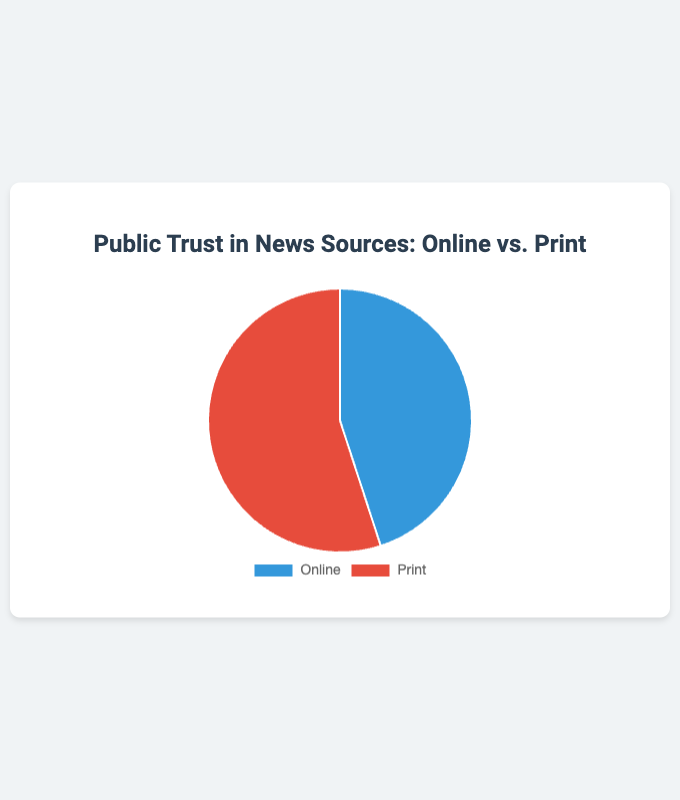Which news source has a higher percentage of public trust? The pie chart shows the percentage of public trust in two news sources: Online and Print. Print has a higher percentage of public trust compared to Online.
Answer: Print What is the percentage difference in public trust between Online and Print news sources? Print has 55% and Online has 45%. The difference is calculated as 55% - 45%.
Answer: 10% What are the respective percentages of public trust for Online and Print news sources? The pie chart directly shows the percentages: Online has 45% and Print has 55% of public trust.
Answer: Online: 45%, Print: 55% What color represents public trust in Print news sources on the pie chart? The pie chart uses different colors to represent each source. The slice for Print news sources is red.
Answer: Red If the percentage of public trust in Online news sources increased by 10%, what would be the new percentage for Online, assuming the total must be 100%? Currently, Online has 45%. An increase of 10% makes it 45% + 10% = 55%. Since the total has to remain at 100%, the percentage for Print would drop accordingly by 10%, making it 55% - 10% = 45%.
Answer: Online: 55%, Print: 45% What fraction of the total public trust is given to Online news sources? Online has 45%. To convert this percentage to a fraction, 45% is equivalent to 45/100 or simplified, 9/20.
Answer: 9/20 If Online trust increases such that it becomes equal to Print trust, what percentage would each have? If Online trust increases to equal Print, both would have half of the total trust. Since the total percentage is 100%, each would then have 100% / 2 = 50%.
Answer: 50% What are the hover background colors of the slices representing Online and Print news sources? The hover background color for Online is a darker shade of blue and for Print, a darker shade of red.
Answer: Online: dark blue, Print: dark red 